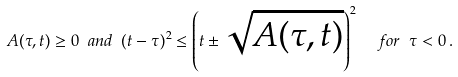<formula> <loc_0><loc_0><loc_500><loc_500>A ( \tau , t ) \geq 0 \ a n d \ ( t - \tau ) ^ { 2 } \leq \left ( t \pm \sqrt { A ( \tau , t ) } \right ) ^ { 2 } \ \ f o r \ \tau < 0 \, .</formula> 